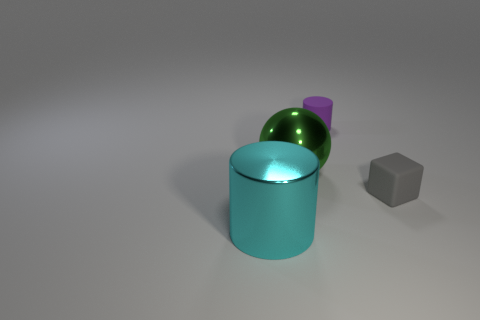There is a tiny rubber thing to the left of the rubber thing in front of the tiny matte cylinder; what shape is it?
Give a very brief answer. Cylinder. Is there a small block made of the same material as the large green sphere?
Ensure brevity in your answer.  No. How many blue things are large cylinders or large objects?
Provide a short and direct response. 0. What is the size of the green thing that is made of the same material as the cyan thing?
Provide a succinct answer. Large. What number of balls are either tiny yellow objects or tiny things?
Ensure brevity in your answer.  0. Is the number of cyan shiny cylinders greater than the number of large brown rubber cubes?
Offer a terse response. Yes. What number of gray things are the same size as the rubber cylinder?
Offer a very short reply. 1. How many things are objects that are to the right of the cyan thing or green things?
Your answer should be compact. 3. Are there fewer gray blocks than large brown balls?
Your response must be concise. No. There is a small object that is made of the same material as the tiny gray cube; what shape is it?
Make the answer very short. Cylinder. 